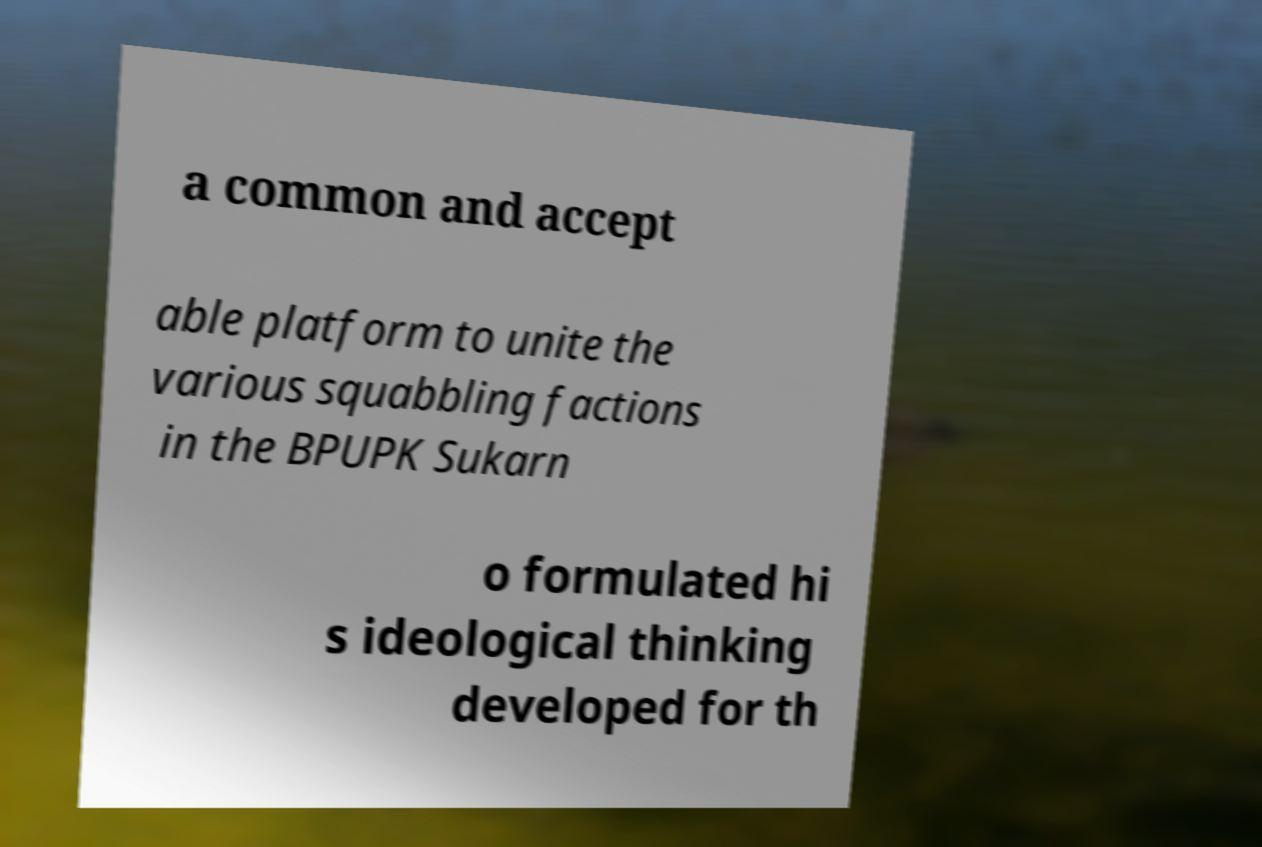Can you accurately transcribe the text from the provided image for me? a common and accept able platform to unite the various squabbling factions in the BPUPK Sukarn o formulated hi s ideological thinking developed for th 